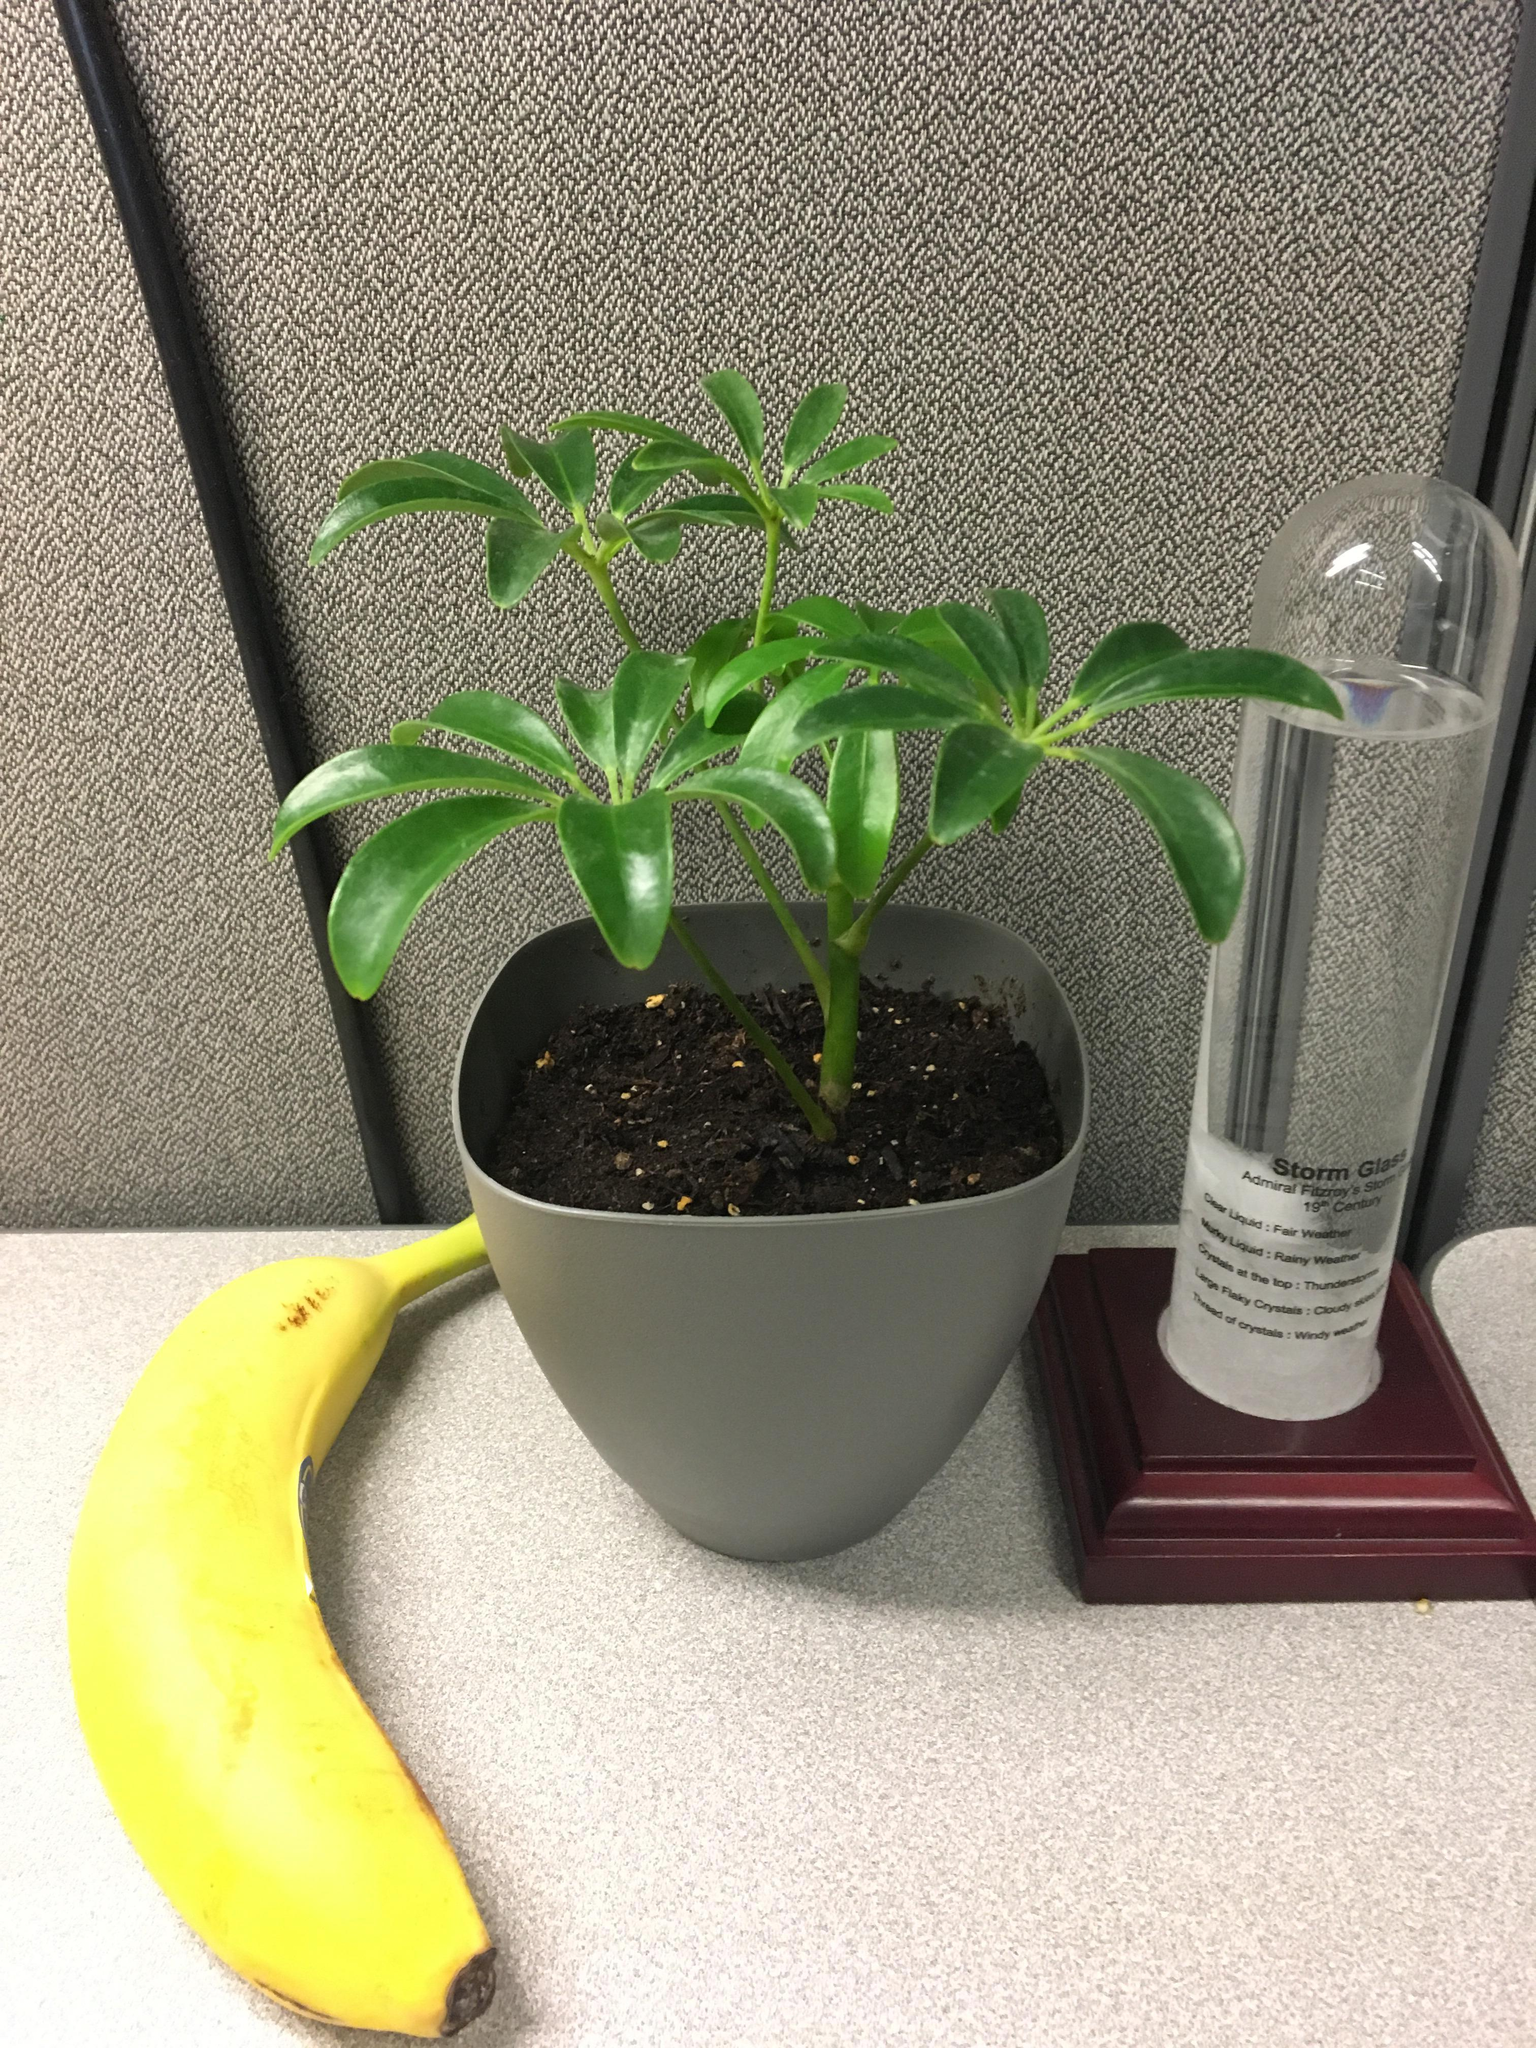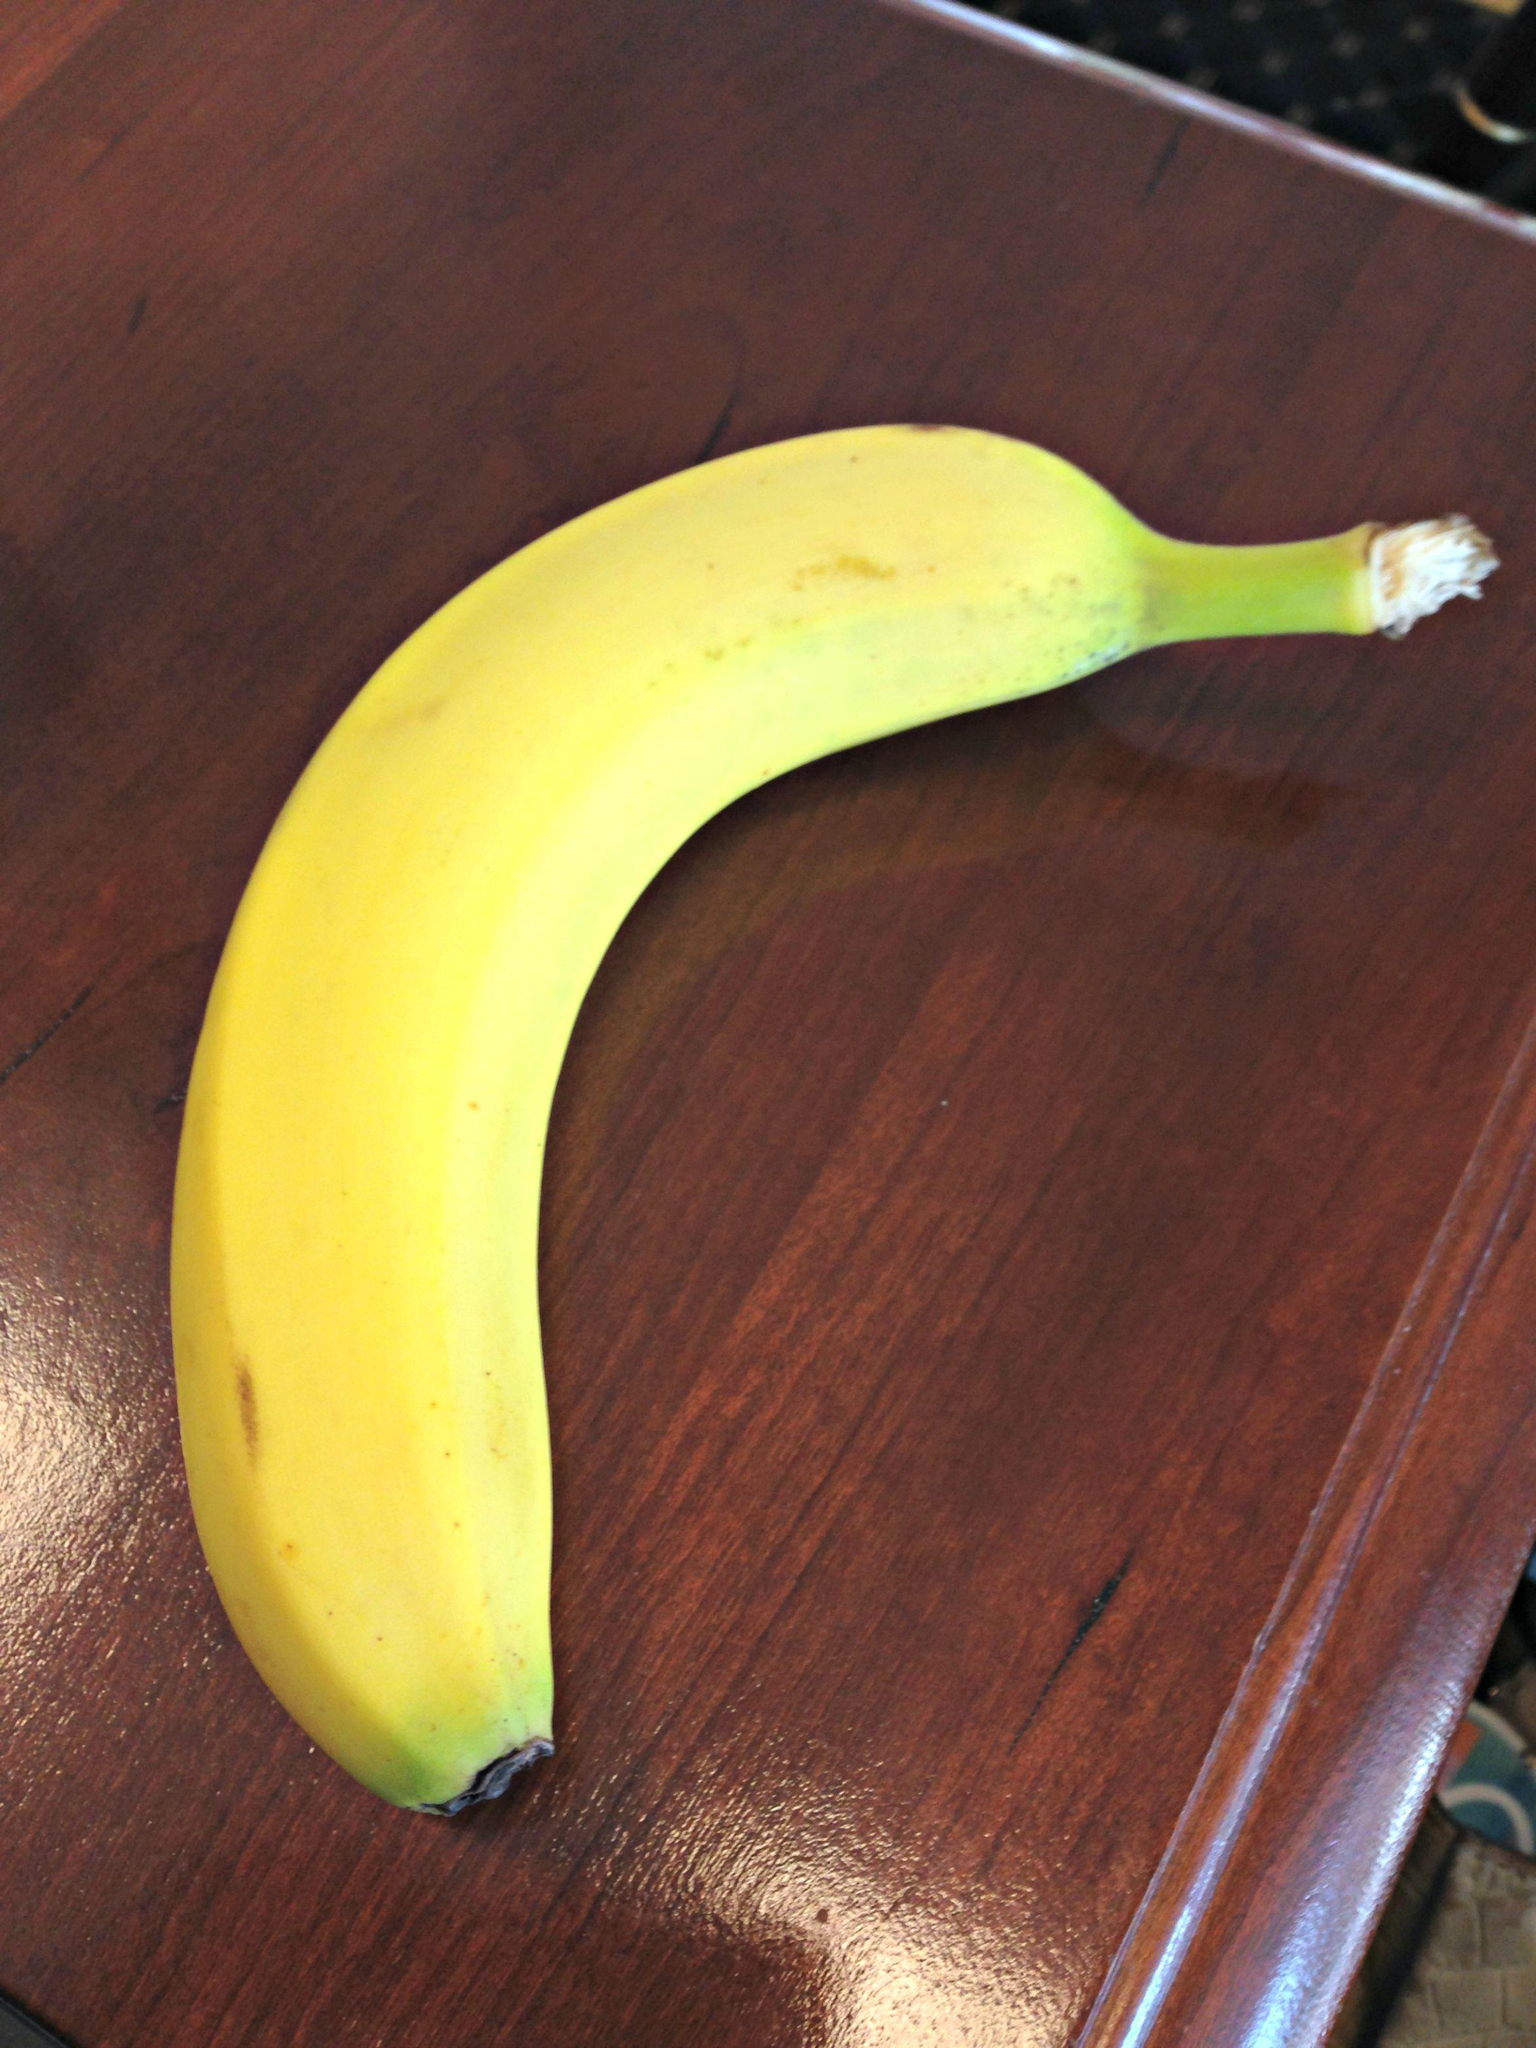The first image is the image on the left, the second image is the image on the right. Evaluate the accuracy of this statement regarding the images: "A banana is on a reddish-brown woodgrain surface in the right image, and a banana is by a cup-like container in the left image.". Is it true? Answer yes or no. Yes. The first image is the image on the left, the second image is the image on the right. Examine the images to the left and right. Is the description "Two bananas are sitting on a desk, and at least one of them is sitting beside a piece of paper." accurate? Answer yes or no. No. 